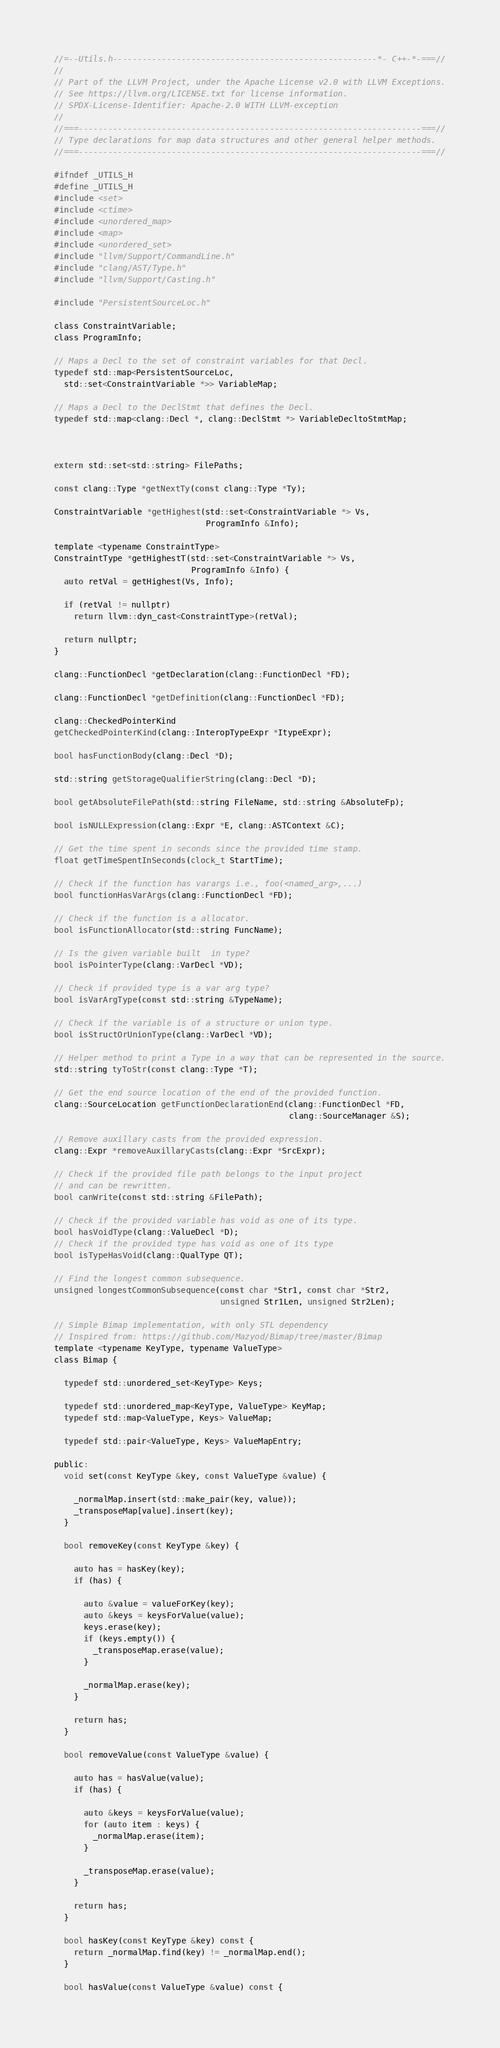<code> <loc_0><loc_0><loc_500><loc_500><_C_>//=--Utils.h------------------------------------------------------*- C++-*-===//
//
// Part of the LLVM Project, under the Apache License v2.0 with LLVM Exceptions.
// See https://llvm.org/LICENSE.txt for license information.
// SPDX-License-Identifier: Apache-2.0 WITH LLVM-exception
//
//===----------------------------------------------------------------------===//
// Type declarations for map data structures and other general helper methods.
//===----------------------------------------------------------------------===//

#ifndef _UTILS_H
#define _UTILS_H
#include <set>
#include <ctime>
#include <unordered_map>
#include <map>
#include <unordered_set>
#include "llvm/Support/CommandLine.h"
#include "clang/AST/Type.h"
#include "llvm/Support/Casting.h"

#include "PersistentSourceLoc.h"

class ConstraintVariable;
class ProgramInfo;

// Maps a Decl to the set of constraint variables for that Decl.
typedef std::map<PersistentSourceLoc, 
  std::set<ConstraintVariable *>> VariableMap;

// Maps a Decl to the DeclStmt that defines the Decl.
typedef std::map<clang::Decl *, clang::DeclStmt *> VariableDecltoStmtMap;



extern std::set<std::string> FilePaths;

const clang::Type *getNextTy(const clang::Type *Ty);

ConstraintVariable *getHighest(std::set<ConstraintVariable *> Vs,
                               ProgramInfo &Info);

template <typename ConstraintType>
ConstraintType *getHighestT(std::set<ConstraintVariable *> Vs,
                            ProgramInfo &Info) {
  auto retVal = getHighest(Vs, Info);

  if (retVal != nullptr)
    return llvm::dyn_cast<ConstraintType>(retVal);

  return nullptr;
}

clang::FunctionDecl *getDeclaration(clang::FunctionDecl *FD);

clang::FunctionDecl *getDefinition(clang::FunctionDecl *FD);

clang::CheckedPointerKind
getCheckedPointerKind(clang::InteropTypeExpr *ItypeExpr);

bool hasFunctionBody(clang::Decl *D);

std::string getStorageQualifierString(clang::Decl *D);

bool getAbsoluteFilePath(std::string FileName, std::string &AbsoluteFp);

bool isNULLExpression(clang::Expr *E, clang::ASTContext &C);

// Get the time spent in seconds since the provided time stamp.
float getTimeSpentInSeconds(clock_t StartTime);

// Check if the function has varargs i.e., foo(<named_arg>,...)
bool functionHasVarArgs(clang::FunctionDecl *FD);

// Check if the function is a allocator.
bool isFunctionAllocator(std::string FuncName);

// Is the given variable built  in type?
bool isPointerType(clang::VarDecl *VD);

// Check if provided type is a var arg type?
bool isVarArgType(const std::string &TypeName);

// Check if the variable is of a structure or union type.
bool isStructOrUnionType(clang::VarDecl *VD);

// Helper method to print a Type in a way that can be represented in the source.
std::string tyToStr(const clang::Type *T);

// Get the end source location of the end of the provided function.
clang::SourceLocation getFunctionDeclarationEnd(clang::FunctionDecl *FD,
                                                clang::SourceManager &S);

// Remove auxillary casts from the provided expression.
clang::Expr *removeAuxillaryCasts(clang::Expr *SrcExpr);

// Check if the provided file path belongs to the input project
// and can be rewritten.
bool canWrite(const std::string &FilePath);

// Check if the provided variable has void as one of its type.
bool hasVoidType(clang::ValueDecl *D);
// Check if the provided type has void as one of its type
bool isTypeHasVoid(clang::QualType QT);

// Find the longest common subsequence.
unsigned longestCommonSubsequence(const char *Str1, const char *Str2,
                                  unsigned Str1Len, unsigned Str2Len);

// Simple Bimap implementation, with only STL dependency
// Inspired from: https://github.com/Mazyod/Bimap/tree/master/Bimap
template <typename KeyType, typename ValueType>
class Bimap {

  typedef std::unordered_set<KeyType> Keys;

  typedef std::unordered_map<KeyType, ValueType> KeyMap;
  typedef std::map<ValueType, Keys> ValueMap;

  typedef std::pair<ValueType, Keys> ValueMapEntry;

public:
  void set(const KeyType &key, const ValueType &value) {

    _normalMap.insert(std::make_pair(key, value));
    _transposeMap[value].insert(key);
  }

  bool removeKey(const KeyType &key) {

    auto has = hasKey(key);
    if (has) {

      auto &value = valueForKey(key);
      auto &keys = keysForValue(value);
      keys.erase(key);
      if (keys.empty()) {
        _transposeMap.erase(value);
      }

      _normalMap.erase(key);
    }

    return has;
  }

  bool removeValue(const ValueType &value) {

    auto has = hasValue(value);
    if (has) {

      auto &keys = keysForValue(value);
      for (auto item : keys) {
        _normalMap.erase(item);
      }

      _transposeMap.erase(value);
    }

    return has;
  }

  bool hasKey(const KeyType &key) const {
    return _normalMap.find(key) != _normalMap.end();
  }

  bool hasValue(const ValueType &value) const {</code> 